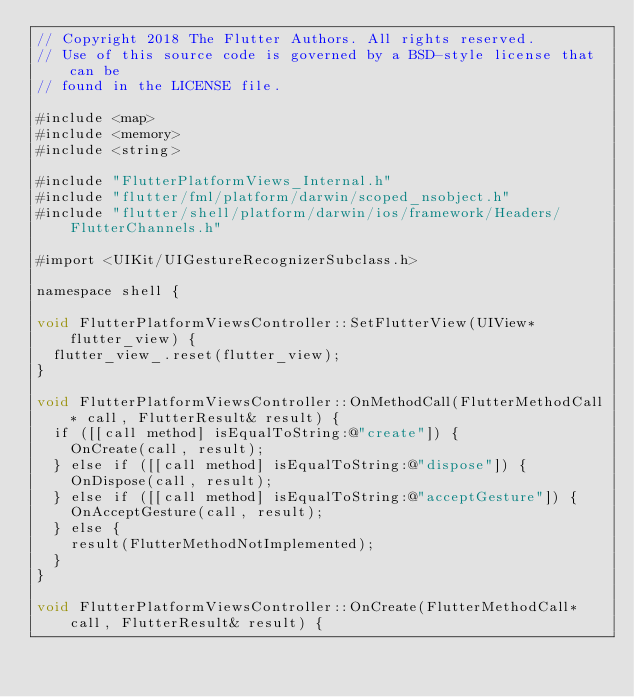<code> <loc_0><loc_0><loc_500><loc_500><_ObjectiveC_>// Copyright 2018 The Flutter Authors. All rights reserved.
// Use of this source code is governed by a BSD-style license that can be
// found in the LICENSE file.

#include <map>
#include <memory>
#include <string>

#include "FlutterPlatformViews_Internal.h"
#include "flutter/fml/platform/darwin/scoped_nsobject.h"
#include "flutter/shell/platform/darwin/ios/framework/Headers/FlutterChannels.h"

#import <UIKit/UIGestureRecognizerSubclass.h>

namespace shell {

void FlutterPlatformViewsController::SetFlutterView(UIView* flutter_view) {
  flutter_view_.reset(flutter_view);
}

void FlutterPlatformViewsController::OnMethodCall(FlutterMethodCall* call, FlutterResult& result) {
  if ([[call method] isEqualToString:@"create"]) {
    OnCreate(call, result);
  } else if ([[call method] isEqualToString:@"dispose"]) {
    OnDispose(call, result);
  } else if ([[call method] isEqualToString:@"acceptGesture"]) {
    OnAcceptGesture(call, result);
  } else {
    result(FlutterMethodNotImplemented);
  }
}

void FlutterPlatformViewsController::OnCreate(FlutterMethodCall* call, FlutterResult& result) {</code> 